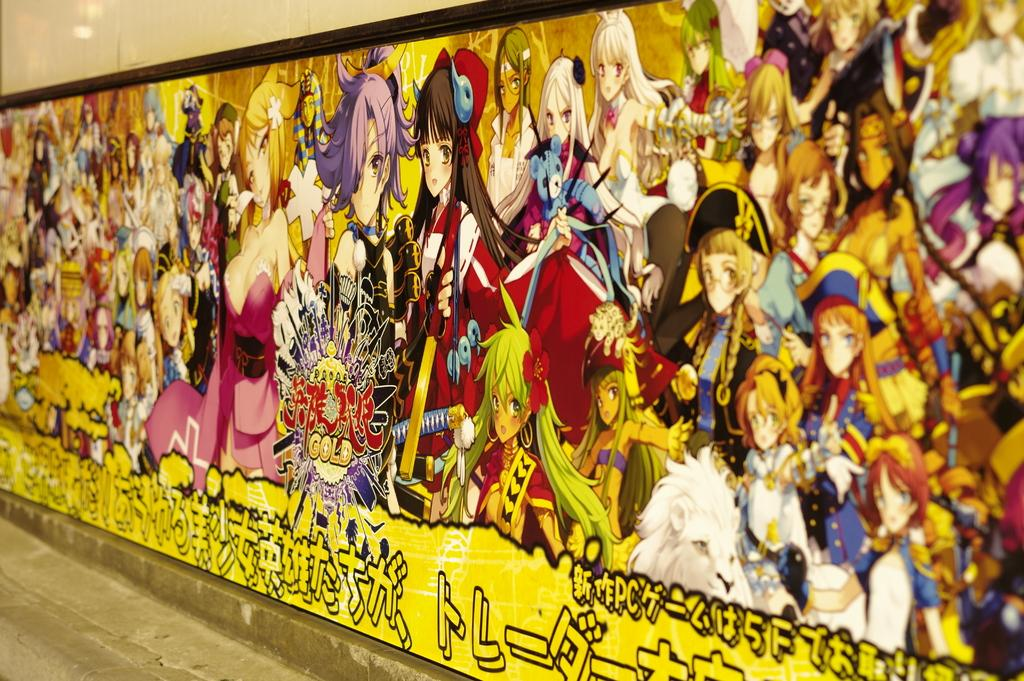What is present on the wall in the image? The wall has an art of cartoon characters in the image. What else can be seen on the wall besides the cartoon characters? There is writing on the wall. Where is the curtain located in the image? There is no curtain present in the image. What type of expansion is shown in the image? There is no expansion depicted in the image; it features a wall with cartoon characters and writing. 